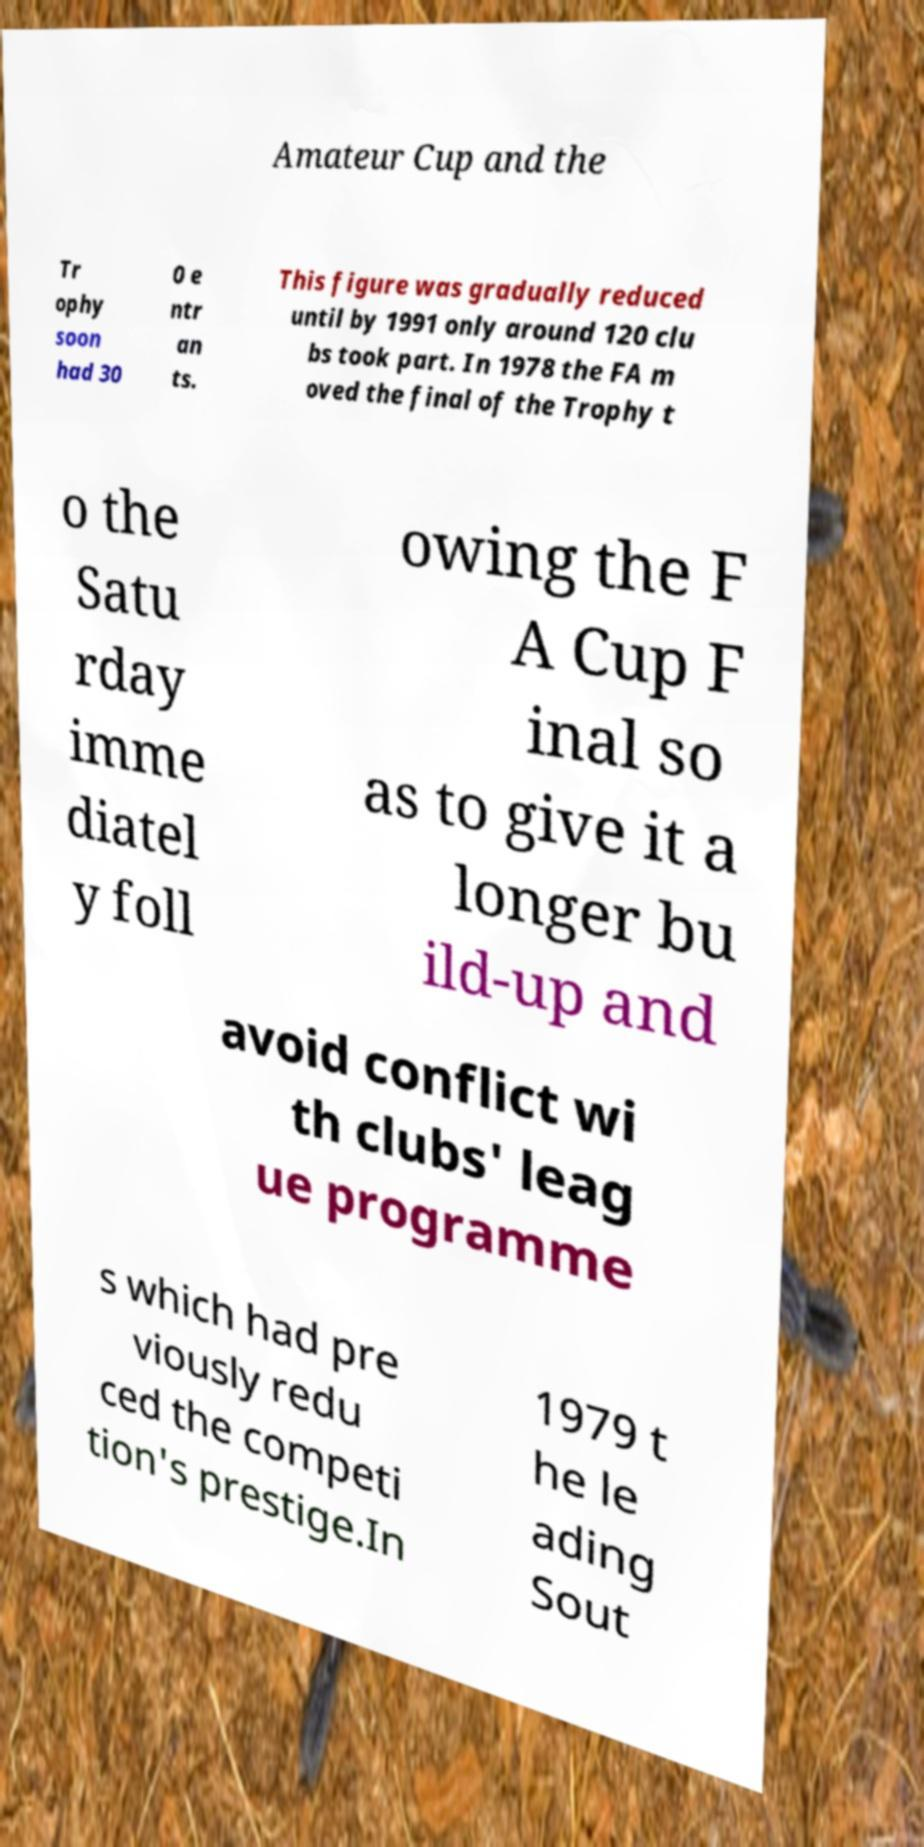Please read and relay the text visible in this image. What does it say? Amateur Cup and the Tr ophy soon had 30 0 e ntr an ts. This figure was gradually reduced until by 1991 only around 120 clu bs took part. In 1978 the FA m oved the final of the Trophy t o the Satu rday imme diatel y foll owing the F A Cup F inal so as to give it a longer bu ild-up and avoid conflict wi th clubs' leag ue programme s which had pre viously redu ced the competi tion's prestige.In 1979 t he le ading Sout 